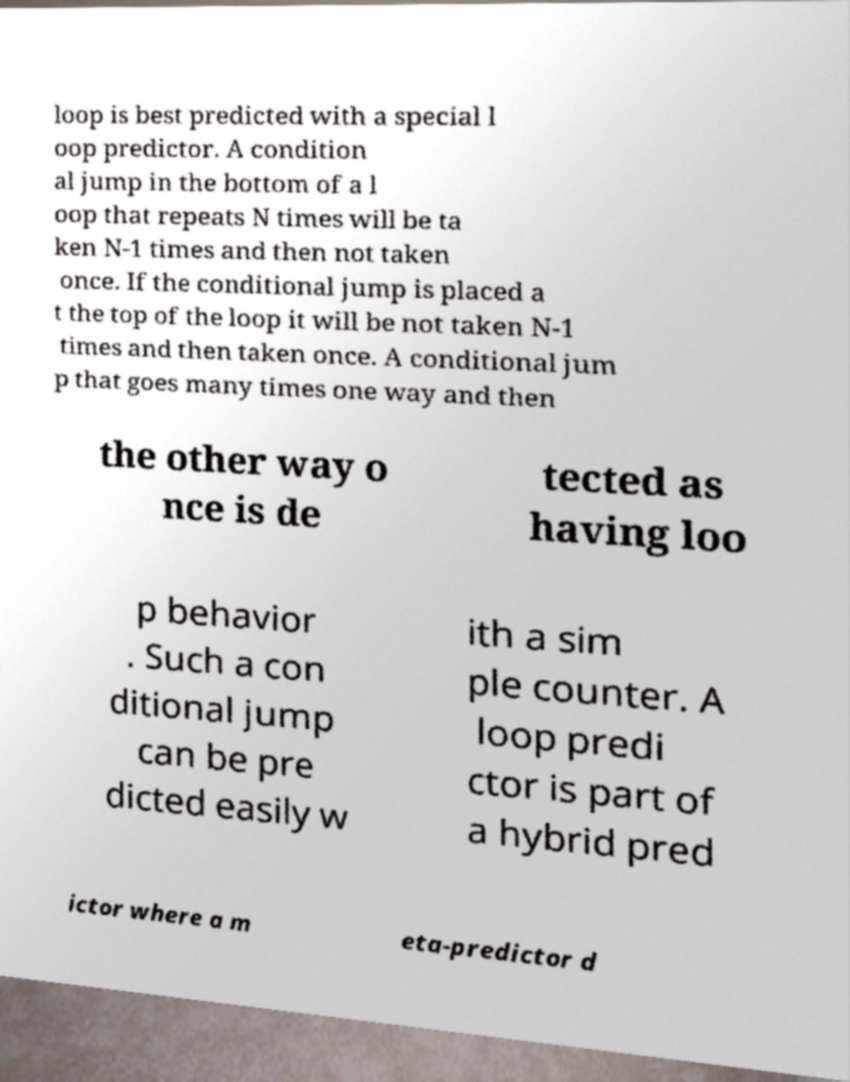There's text embedded in this image that I need extracted. Can you transcribe it verbatim? loop is best predicted with a special l oop predictor. A condition al jump in the bottom of a l oop that repeats N times will be ta ken N-1 times and then not taken once. If the conditional jump is placed a t the top of the loop it will be not taken N-1 times and then taken once. A conditional jum p that goes many times one way and then the other way o nce is de tected as having loo p behavior . Such a con ditional jump can be pre dicted easily w ith a sim ple counter. A loop predi ctor is part of a hybrid pred ictor where a m eta-predictor d 